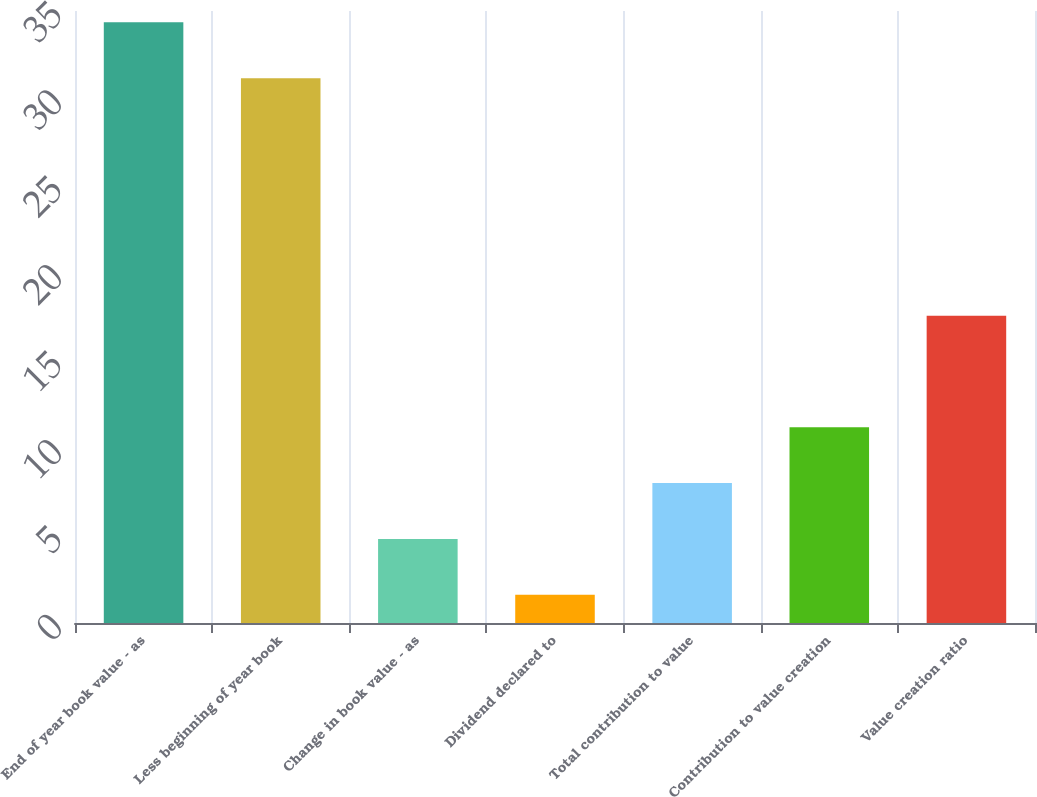Convert chart. <chart><loc_0><loc_0><loc_500><loc_500><bar_chart><fcel>End of year book value - as<fcel>Less beginning of year book<fcel>Change in book value - as<fcel>Dividend declared to<fcel>Total contribution to value<fcel>Contribution to value creation<fcel>Value creation ratio<nl><fcel>34.35<fcel>31.16<fcel>4.81<fcel>1.62<fcel>8<fcel>11.19<fcel>17.57<nl></chart> 